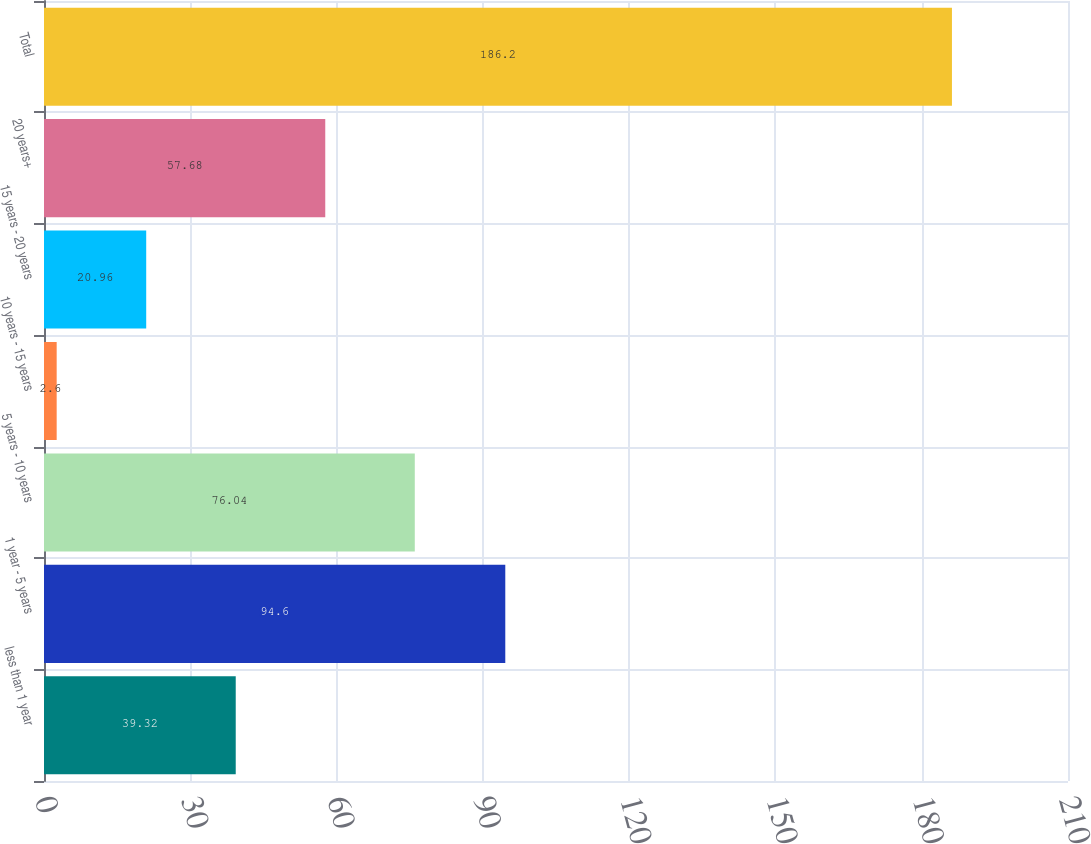Convert chart to OTSL. <chart><loc_0><loc_0><loc_500><loc_500><bar_chart><fcel>less than 1 year<fcel>1 year - 5 years<fcel>5 years - 10 years<fcel>10 years - 15 years<fcel>15 years - 20 years<fcel>20 years+<fcel>Total<nl><fcel>39.32<fcel>94.6<fcel>76.04<fcel>2.6<fcel>20.96<fcel>57.68<fcel>186.2<nl></chart> 